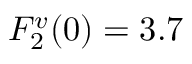Convert formula to latex. <formula><loc_0><loc_0><loc_500><loc_500>F _ { 2 } ^ { v } ( 0 ) = 3 . 7</formula> 